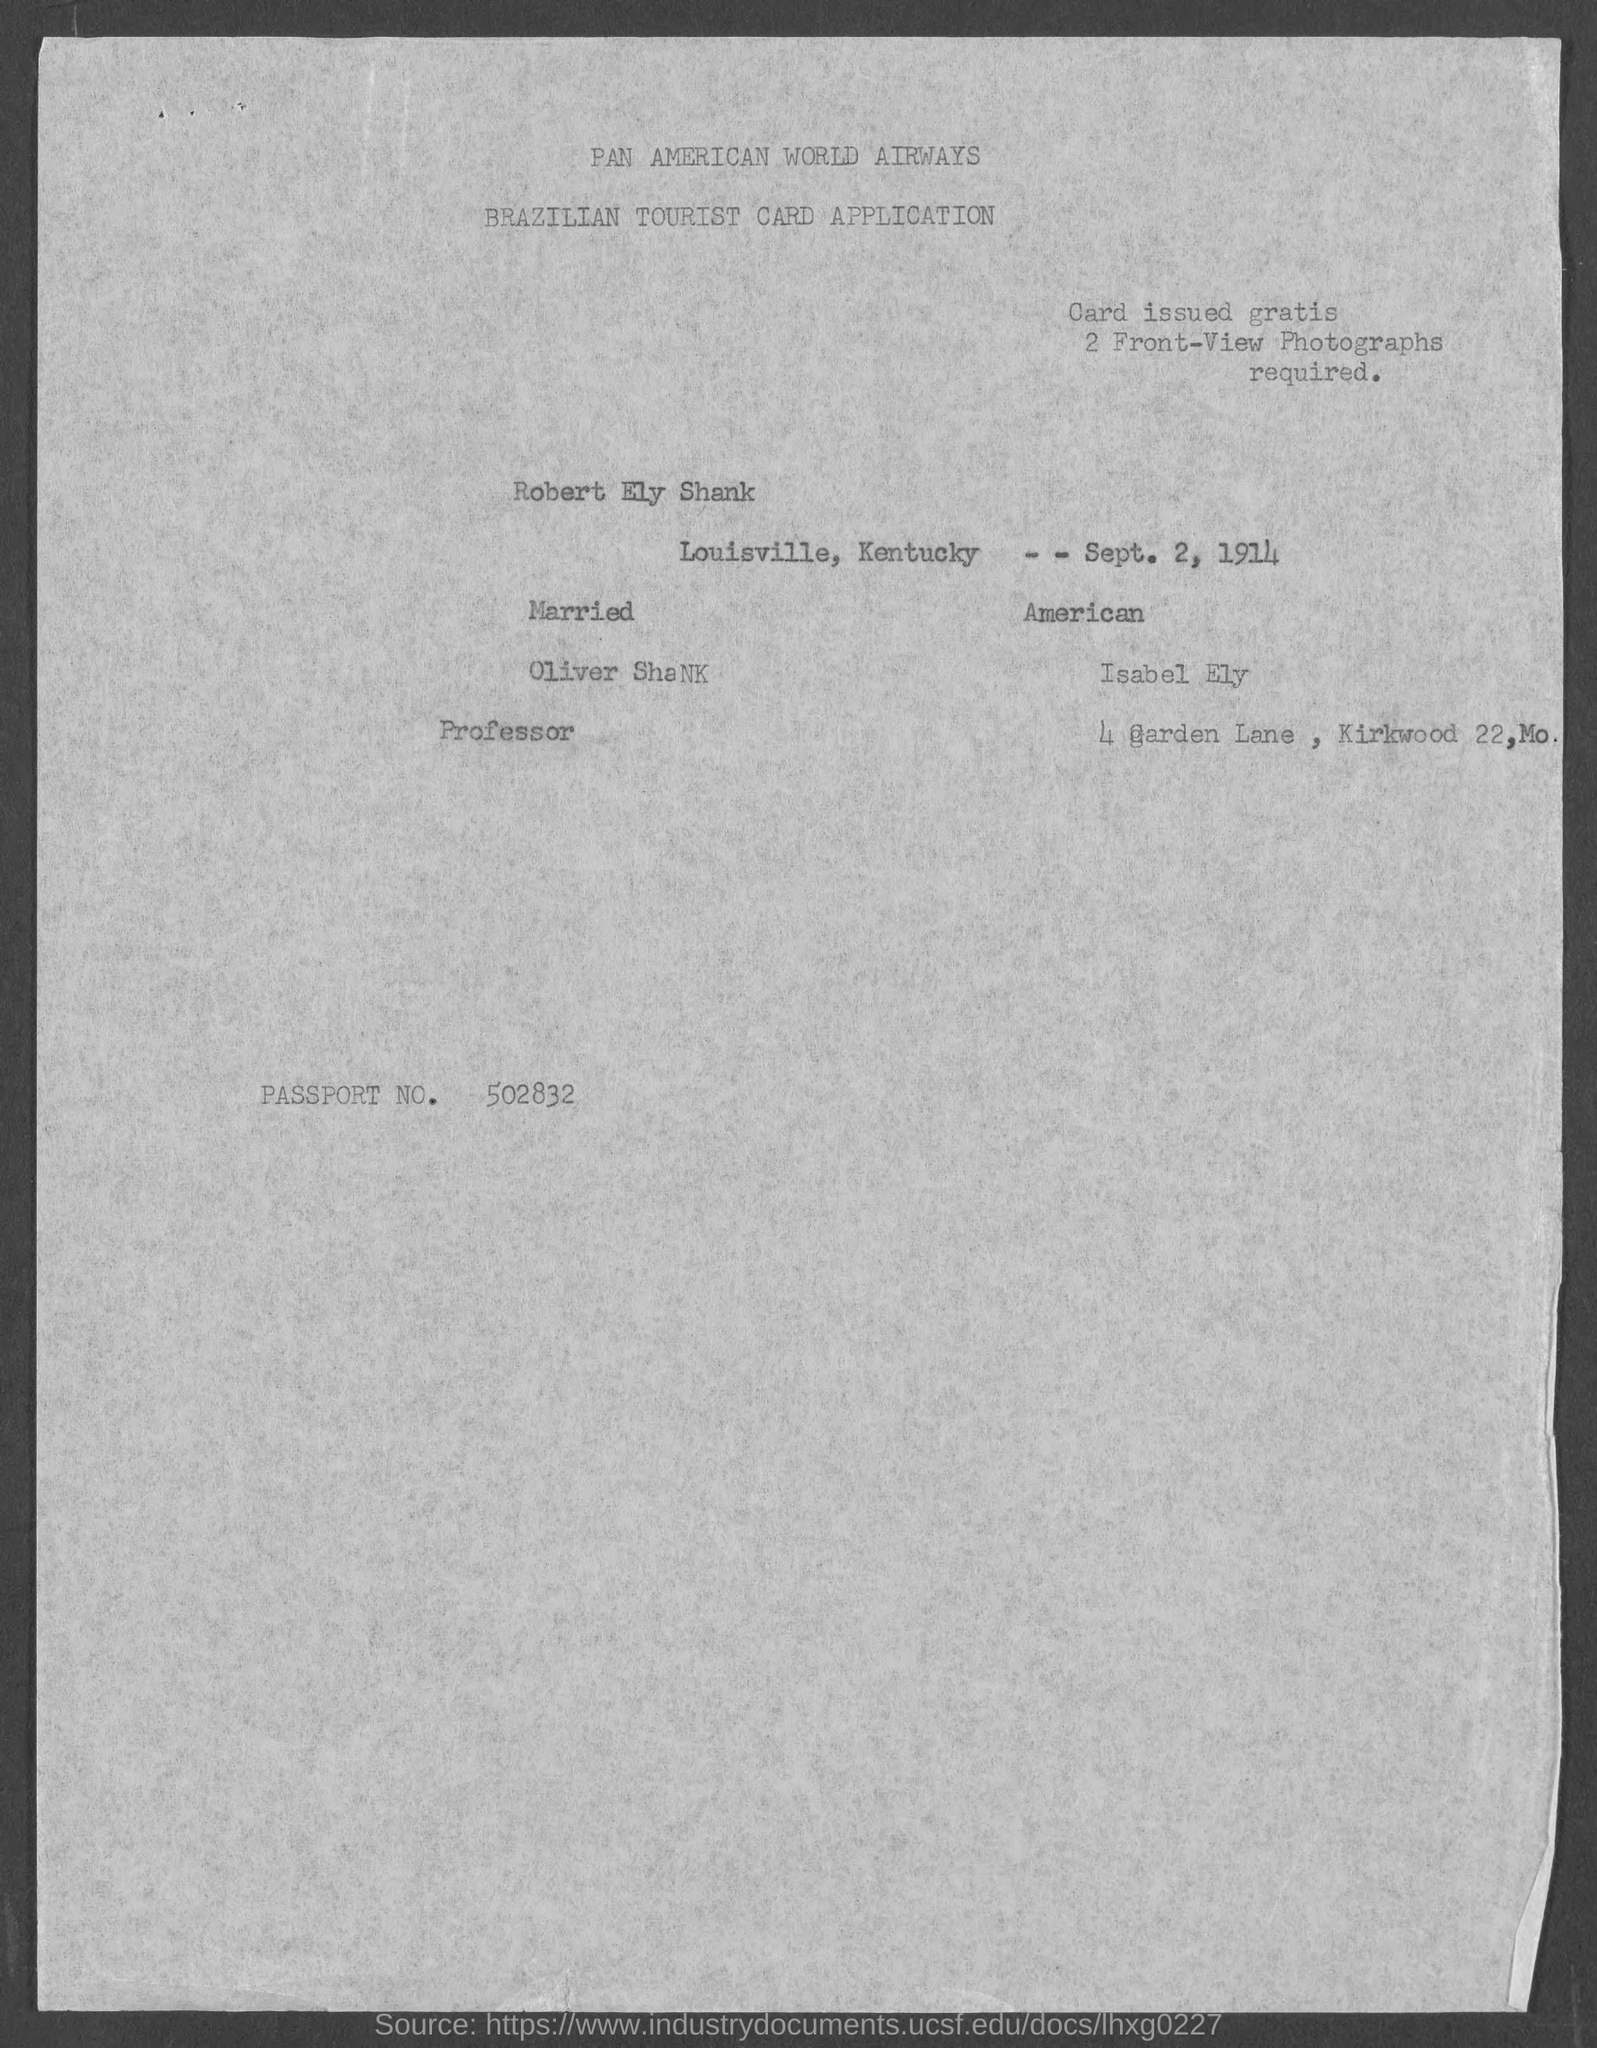Point out several critical features in this image. What is the passport number? 